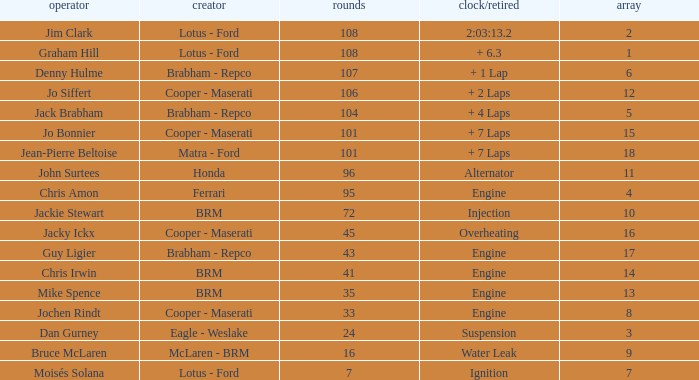What was the constructor when there were 95 laps and a grid less than 15? Ferrari. 